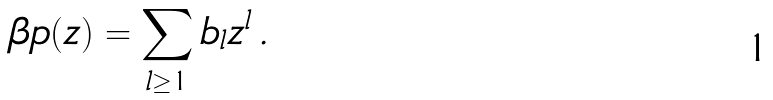Convert formula to latex. <formula><loc_0><loc_0><loc_500><loc_500>\beta p ( z ) = \sum _ { l \geq 1 } b _ { l } z ^ { l } \, .</formula> 